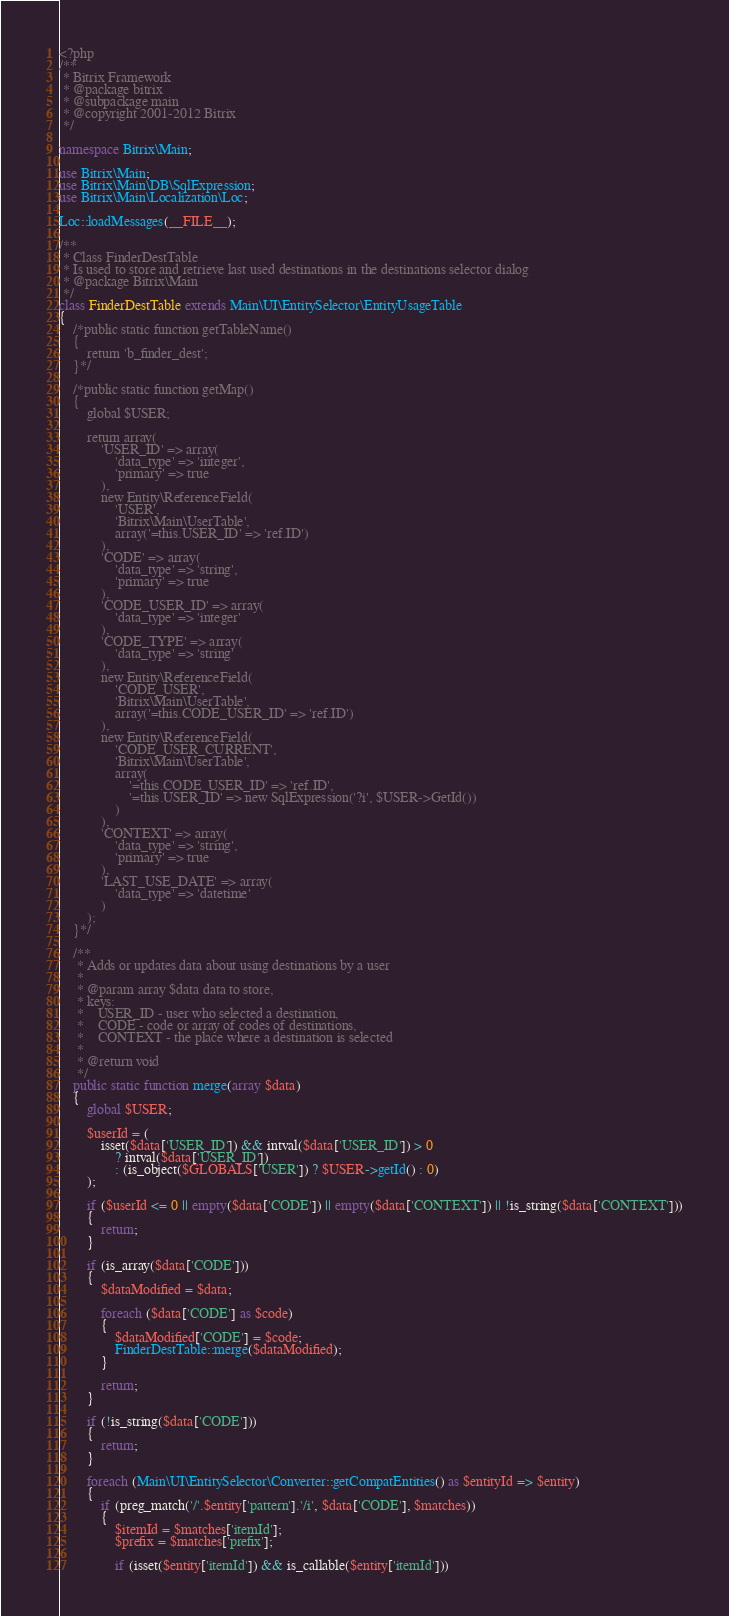Convert code to text. <code><loc_0><loc_0><loc_500><loc_500><_PHP_><?php
/**
 * Bitrix Framework
 * @package bitrix
 * @subpackage main
 * @copyright 2001-2012 Bitrix
 */

namespace Bitrix\Main;

use Bitrix\Main;
use Bitrix\Main\DB\SqlExpression;
use Bitrix\Main\Localization\Loc;

Loc::loadMessages(__FILE__);

/**
 * Class FinderDestTable
 * Is used to store and retrieve last used destinations in the destinations selector dialog
 * @package Bitrix\Main
 */
class FinderDestTable extends Main\UI\EntitySelector\EntityUsageTable
{
	/*public static function getTableName()
	{
		return 'b_finder_dest';
	}*/

	/*public static function getMap()
	{
		global $USER;

		return array(
			'USER_ID' => array(
				'data_type' => 'integer',
				'primary' => true
			),
			new Entity\ReferenceField(
				'USER',
				'Bitrix\Main\UserTable',
				array('=this.USER_ID' => 'ref.ID')
			),
			'CODE' => array(
				'data_type' => 'string',
				'primary' => true
			),
			'CODE_USER_ID' => array(
				'data_type' => 'integer'
			),
			'CODE_TYPE' => array(
				'data_type' => 'string'
			),
			new Entity\ReferenceField(
				'CODE_USER',
				'Bitrix\Main\UserTable',
				array('=this.CODE_USER_ID' => 'ref.ID')
			),
			new Entity\ReferenceField(
				'CODE_USER_CURRENT',
				'Bitrix\Main\UserTable',
				array(
					'=this.CODE_USER_ID' => 'ref.ID',
					'=this.USER_ID' => new SqlExpression('?i', $USER->GetId())
				)
			),
			'CONTEXT' => array(
				'data_type' => 'string',
				'primary' => true
			),
			'LAST_USE_DATE' => array(
				'data_type' => 'datetime'
			)
		);
	}*/

	/**
	 * Adds or updates data about using destinations by a user
	 *
	 * @param array $data data to store,
	 * keys:
	 *    USER_ID - user who selected a destination,
	 *    CODE - code or array of codes of destinations,
	 *    CONTEXT - the place where a destination is selected
	 *
	 * @return void
	 */
	public static function merge(array $data)
	{
		global $USER;

		$userId = (
			isset($data['USER_ID']) && intval($data['USER_ID']) > 0
				? intval($data['USER_ID'])
				: (is_object($GLOBALS['USER']) ? $USER->getId() : 0)
		);

		if ($userId <= 0 || empty($data['CODE']) || empty($data['CONTEXT']) || !is_string($data['CONTEXT']))
		{
			return;
		}

		if (is_array($data['CODE']))
		{
			$dataModified = $data;

			foreach ($data['CODE'] as $code)
			{
				$dataModified['CODE'] = $code;
				FinderDestTable::merge($dataModified);
			}

			return;
		}

		if (!is_string($data['CODE']))
		{
			return;
		}

		foreach (Main\UI\EntitySelector\Converter::getCompatEntities() as $entityId => $entity)
		{
			if (preg_match('/'.$entity['pattern'].'/i', $data['CODE'], $matches))
			{
				$itemId = $matches['itemId'];
				$prefix = $matches['prefix'];

				if (isset($entity['itemId']) && is_callable($entity['itemId']))</code> 